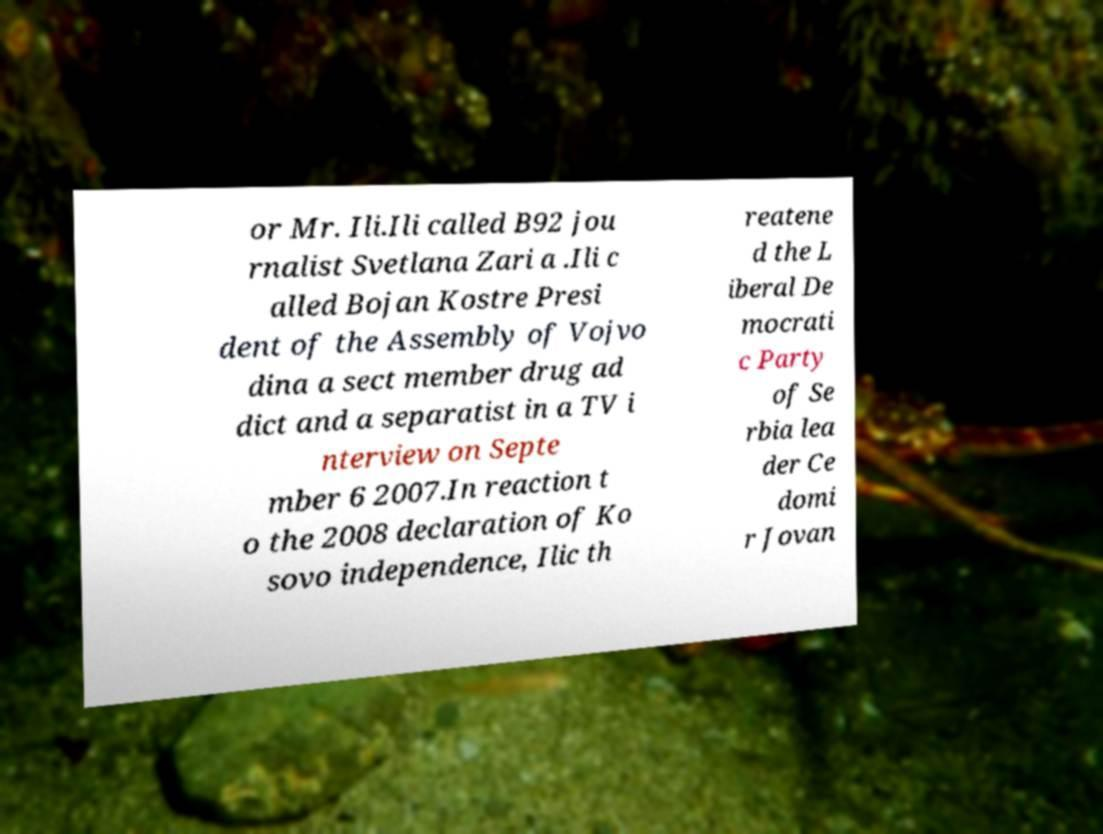Can you read and provide the text displayed in the image?This photo seems to have some interesting text. Can you extract and type it out for me? or Mr. Ili.Ili called B92 jou rnalist Svetlana Zari a .Ili c alled Bojan Kostre Presi dent of the Assembly of Vojvo dina a sect member drug ad dict and a separatist in a TV i nterview on Septe mber 6 2007.In reaction t o the 2008 declaration of Ko sovo independence, Ilic th reatene d the L iberal De mocrati c Party of Se rbia lea der Ce domi r Jovan 